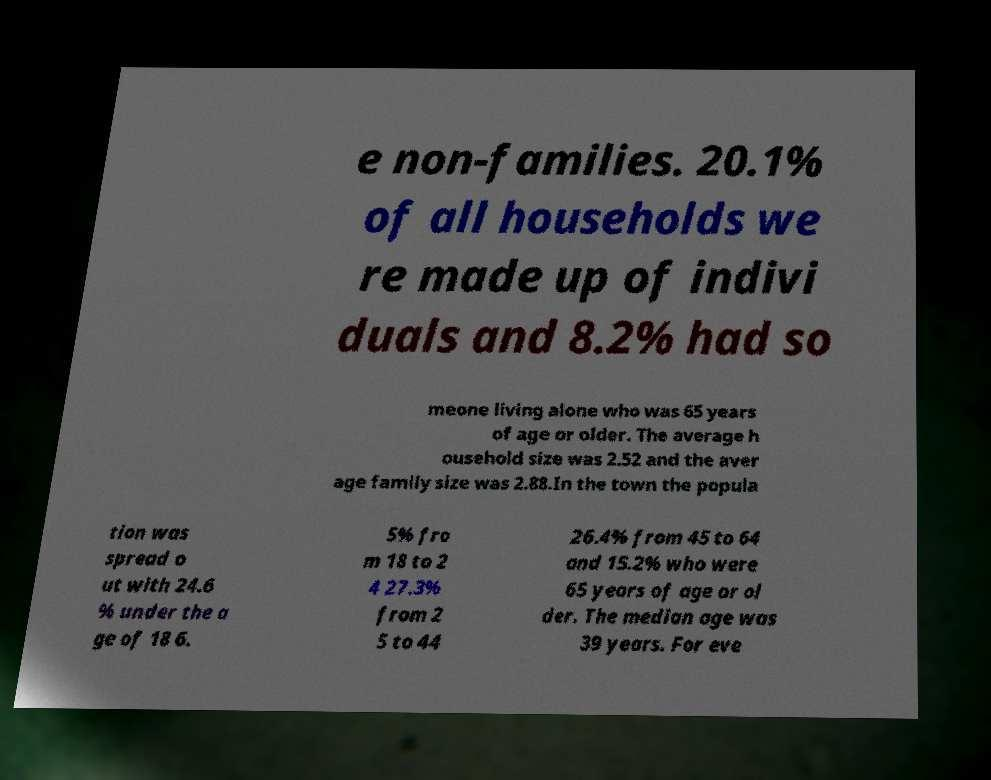Can you accurately transcribe the text from the provided image for me? e non-families. 20.1% of all households we re made up of indivi duals and 8.2% had so meone living alone who was 65 years of age or older. The average h ousehold size was 2.52 and the aver age family size was 2.88.In the town the popula tion was spread o ut with 24.6 % under the a ge of 18 6. 5% fro m 18 to 2 4 27.3% from 2 5 to 44 26.4% from 45 to 64 and 15.2% who were 65 years of age or ol der. The median age was 39 years. For eve 